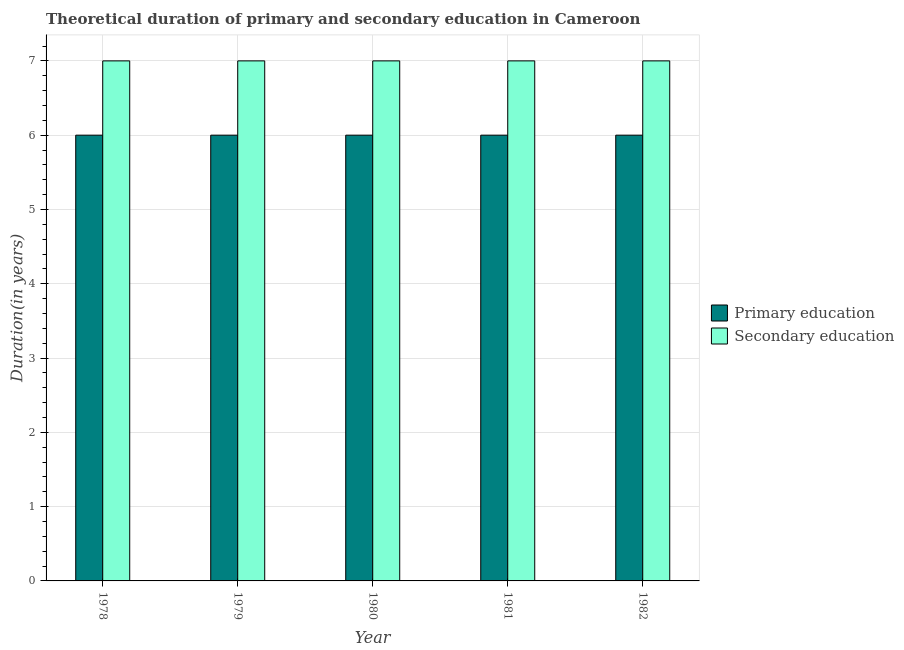How many groups of bars are there?
Your response must be concise. 5. How many bars are there on the 2nd tick from the left?
Provide a succinct answer. 2. How many bars are there on the 3rd tick from the right?
Your response must be concise. 2. What is the label of the 2nd group of bars from the left?
Your answer should be very brief. 1979. In how many cases, is the number of bars for a given year not equal to the number of legend labels?
Offer a very short reply. 0. What is the duration of secondary education in 1981?
Provide a short and direct response. 7. Across all years, what is the minimum duration of secondary education?
Offer a very short reply. 7. In which year was the duration of secondary education maximum?
Your response must be concise. 1978. In which year was the duration of secondary education minimum?
Provide a short and direct response. 1978. What is the total duration of primary education in the graph?
Offer a very short reply. 30. What is the average duration of primary education per year?
Keep it short and to the point. 6. In how many years, is the duration of secondary education greater than 4.2 years?
Give a very brief answer. 5. Is the difference between the duration of secondary education in 1978 and 1981 greater than the difference between the duration of primary education in 1978 and 1981?
Your response must be concise. No. Is the sum of the duration of primary education in 1980 and 1982 greater than the maximum duration of secondary education across all years?
Offer a terse response. Yes. What does the 2nd bar from the left in 1981 represents?
Give a very brief answer. Secondary education. What does the 1st bar from the right in 1978 represents?
Give a very brief answer. Secondary education. How many bars are there?
Your answer should be very brief. 10. What is the title of the graph?
Make the answer very short. Theoretical duration of primary and secondary education in Cameroon. Does "current US$" appear as one of the legend labels in the graph?
Offer a very short reply. No. What is the label or title of the X-axis?
Give a very brief answer. Year. What is the label or title of the Y-axis?
Provide a short and direct response. Duration(in years). What is the Duration(in years) in Primary education in 1978?
Offer a very short reply. 6. What is the Duration(in years) of Primary education in 1979?
Provide a succinct answer. 6. What is the Duration(in years) of Secondary education in 1980?
Give a very brief answer. 7. What is the Duration(in years) of Secondary education in 1981?
Provide a succinct answer. 7. What is the Duration(in years) of Secondary education in 1982?
Provide a short and direct response. 7. Across all years, what is the maximum Duration(in years) of Primary education?
Offer a very short reply. 6. Across all years, what is the maximum Duration(in years) in Secondary education?
Give a very brief answer. 7. Across all years, what is the minimum Duration(in years) of Primary education?
Keep it short and to the point. 6. Across all years, what is the minimum Duration(in years) in Secondary education?
Provide a short and direct response. 7. What is the total Duration(in years) of Primary education in the graph?
Provide a short and direct response. 30. What is the difference between the Duration(in years) in Primary education in 1978 and that in 1979?
Provide a succinct answer. 0. What is the difference between the Duration(in years) in Secondary education in 1978 and that in 1979?
Ensure brevity in your answer.  0. What is the difference between the Duration(in years) in Primary education in 1978 and that in 1980?
Your response must be concise. 0. What is the difference between the Duration(in years) in Secondary education in 1978 and that in 1980?
Your answer should be very brief. 0. What is the difference between the Duration(in years) of Primary education in 1978 and that in 1981?
Offer a terse response. 0. What is the difference between the Duration(in years) of Secondary education in 1978 and that in 1982?
Your response must be concise. 0. What is the difference between the Duration(in years) in Primary education in 1979 and that in 1980?
Keep it short and to the point. 0. What is the difference between the Duration(in years) in Secondary education in 1979 and that in 1980?
Give a very brief answer. 0. What is the difference between the Duration(in years) of Primary education in 1979 and that in 1981?
Your answer should be compact. 0. What is the difference between the Duration(in years) of Secondary education in 1979 and that in 1981?
Provide a short and direct response. 0. What is the difference between the Duration(in years) in Secondary education in 1979 and that in 1982?
Provide a succinct answer. 0. What is the difference between the Duration(in years) in Primary education in 1980 and that in 1981?
Offer a very short reply. 0. What is the difference between the Duration(in years) in Secondary education in 1980 and that in 1981?
Make the answer very short. 0. What is the difference between the Duration(in years) of Secondary education in 1980 and that in 1982?
Offer a terse response. 0. What is the difference between the Duration(in years) of Primary education in 1981 and that in 1982?
Your response must be concise. 0. What is the difference between the Duration(in years) of Primary education in 1978 and the Duration(in years) of Secondary education in 1981?
Give a very brief answer. -1. What is the difference between the Duration(in years) in Primary education in 1981 and the Duration(in years) in Secondary education in 1982?
Offer a very short reply. -1. What is the average Duration(in years) of Primary education per year?
Your answer should be very brief. 6. In the year 1981, what is the difference between the Duration(in years) of Primary education and Duration(in years) of Secondary education?
Offer a very short reply. -1. In the year 1982, what is the difference between the Duration(in years) of Primary education and Duration(in years) of Secondary education?
Your response must be concise. -1. What is the ratio of the Duration(in years) in Primary education in 1978 to that in 1979?
Keep it short and to the point. 1. What is the ratio of the Duration(in years) of Secondary education in 1978 to that in 1979?
Provide a short and direct response. 1. What is the ratio of the Duration(in years) of Secondary education in 1978 to that in 1980?
Offer a terse response. 1. What is the ratio of the Duration(in years) in Primary education in 1978 to that in 1981?
Provide a succinct answer. 1. What is the ratio of the Duration(in years) of Secondary education in 1978 to that in 1981?
Ensure brevity in your answer.  1. What is the ratio of the Duration(in years) in Primary education in 1978 to that in 1982?
Offer a very short reply. 1. What is the ratio of the Duration(in years) in Primary education in 1979 to that in 1980?
Your answer should be very brief. 1. What is the ratio of the Duration(in years) in Secondary education in 1979 to that in 1981?
Keep it short and to the point. 1. What is the ratio of the Duration(in years) in Primary education in 1979 to that in 1982?
Provide a succinct answer. 1. What is the ratio of the Duration(in years) of Secondary education in 1981 to that in 1982?
Offer a very short reply. 1. What is the difference between the highest and the second highest Duration(in years) in Primary education?
Make the answer very short. 0. What is the difference between the highest and the second highest Duration(in years) of Secondary education?
Provide a succinct answer. 0. What is the difference between the highest and the lowest Duration(in years) in Primary education?
Ensure brevity in your answer.  0. What is the difference between the highest and the lowest Duration(in years) in Secondary education?
Make the answer very short. 0. 